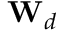Convert formula to latex. <formula><loc_0><loc_0><loc_500><loc_500>W _ { d }</formula> 